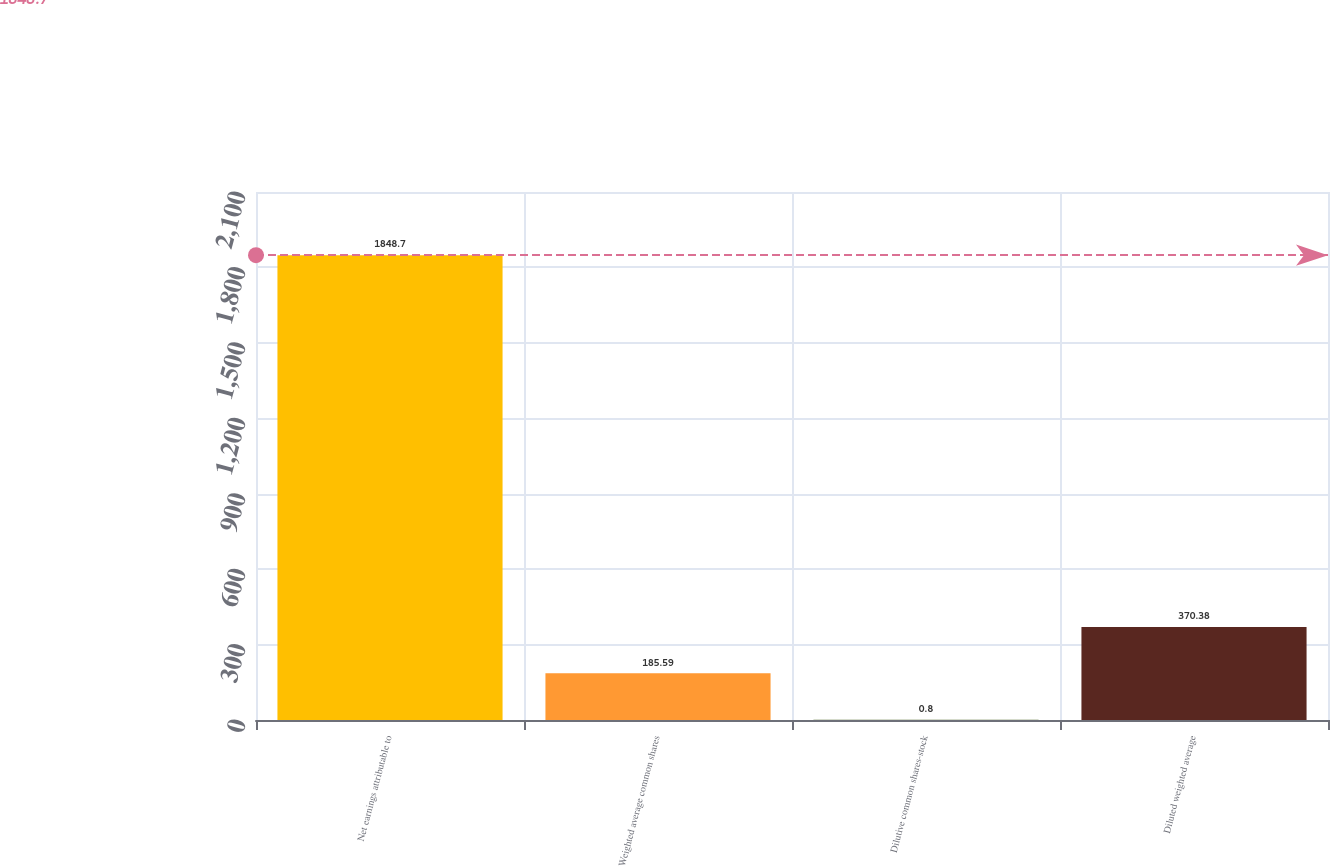Convert chart. <chart><loc_0><loc_0><loc_500><loc_500><bar_chart><fcel>Net earnings attributable to<fcel>Weighted average common shares<fcel>Dilutive common shares-stock<fcel>Diluted weighted average<nl><fcel>1848.7<fcel>185.59<fcel>0.8<fcel>370.38<nl></chart> 